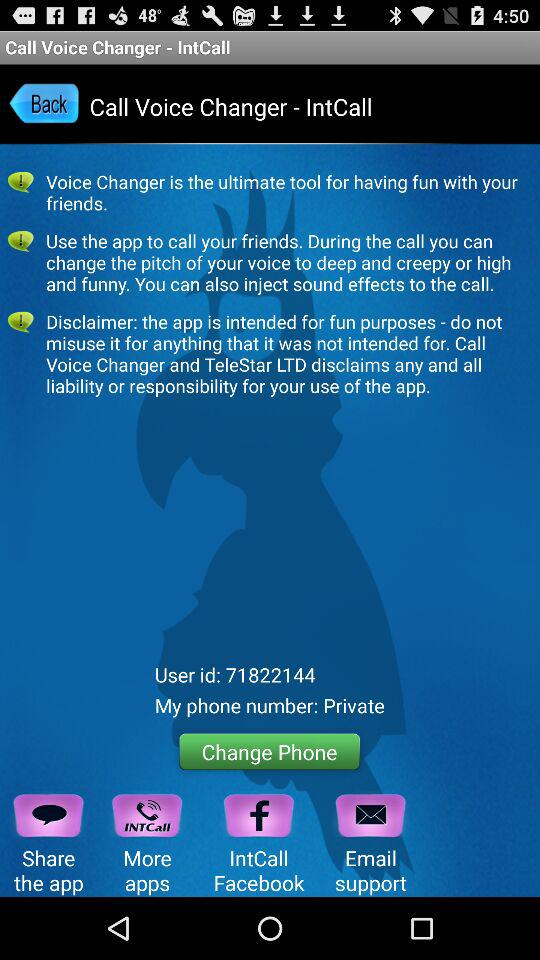What is the type of my phone number? The type of my phone number is private. 